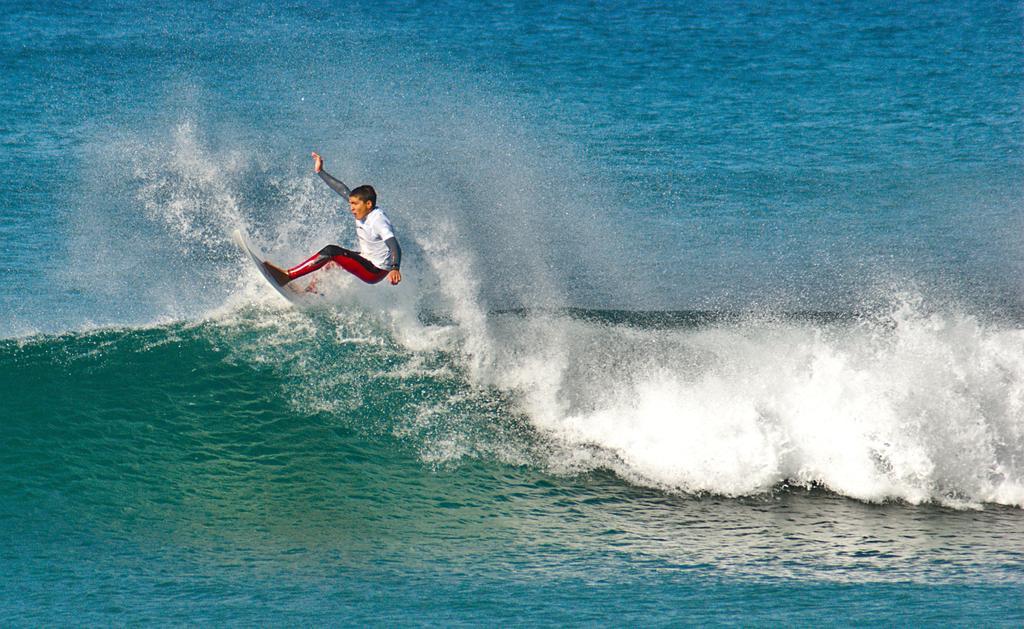How would you summarize this image in a sentence or two? In this image, we can see a person surfing on the water. 